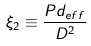<formula> <loc_0><loc_0><loc_500><loc_500>\xi _ { 2 } \equiv \frac { P d _ { e f f } } { D ^ { 2 } }</formula> 